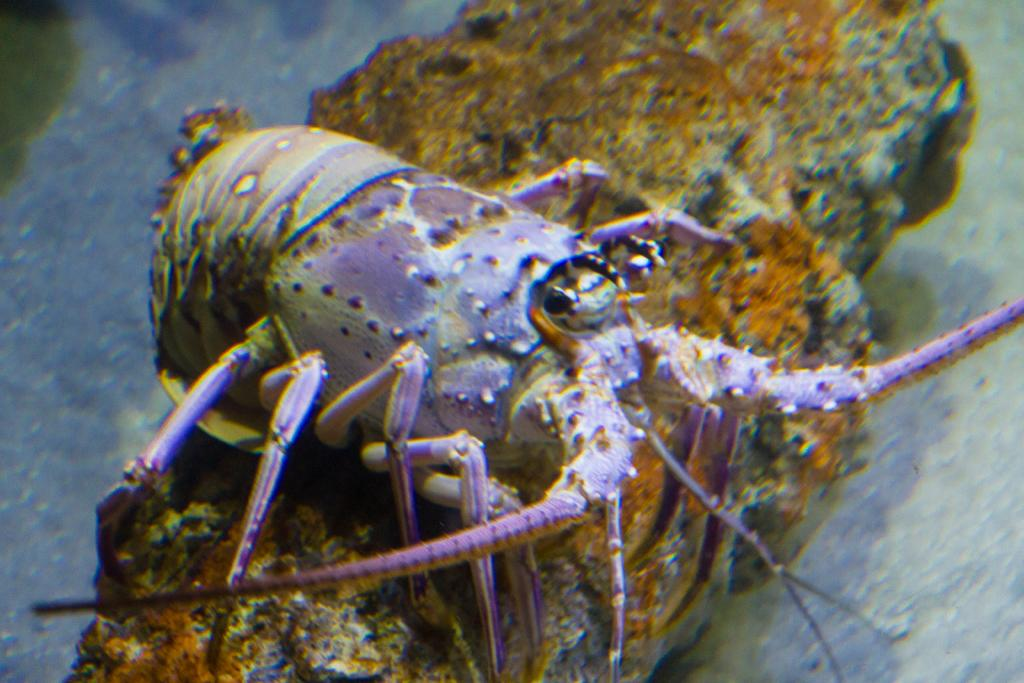What type of environment is shown in the image? The image depicts an underwater environment. Can you identify any specific creatures in the image? Yes, there is a crab in the middle of the image. What type of relation does the monkey have with the crab in the image? There is no monkey present in the image, so it is not possible to determine any relation between a monkey and the crab. 